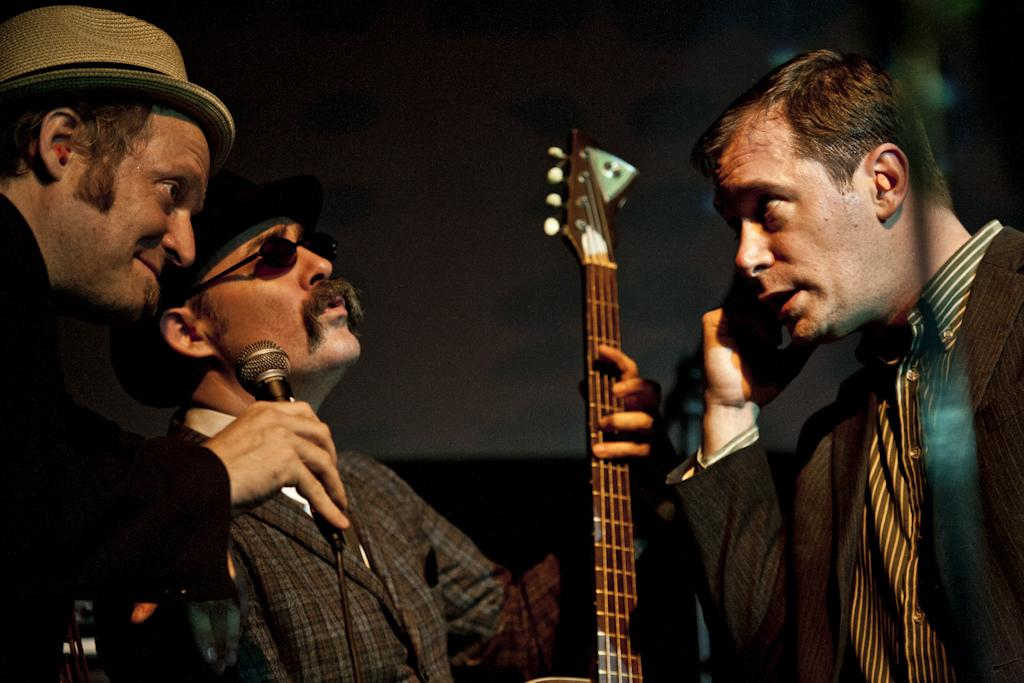How many people are in the image? There are three men in the image. What is one of the men holding? One of the men is holding a microphone. What is the other man holding? Another man is holding a musical instrument. What type of machine can be seen in the background of the image? There is no machine visible in the background of the image. How many pizzas are being served to the men in the image? There is no mention of pizzas in the image, so it cannot be determined how many pizzas are being served. 